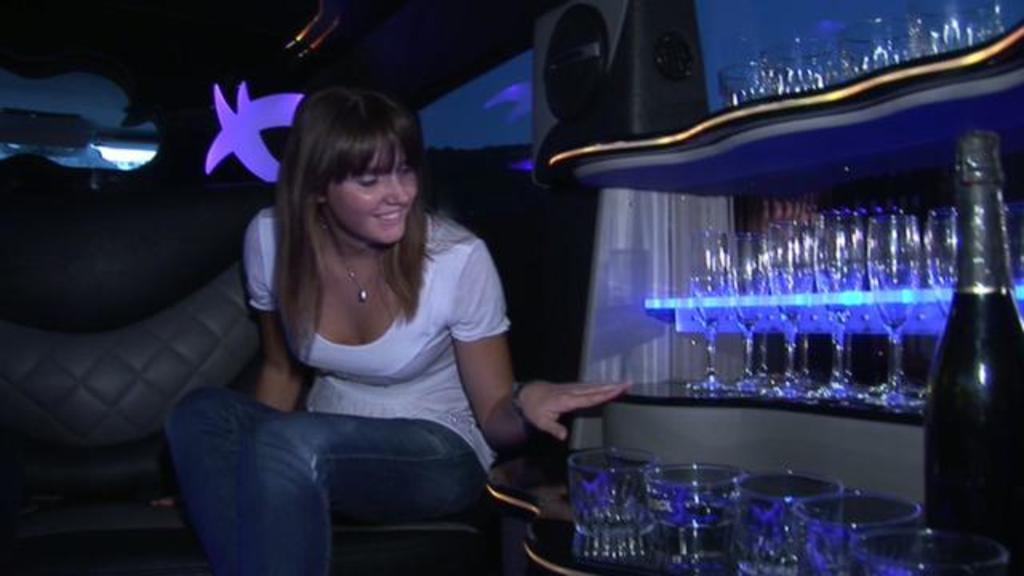What is the woman in the image doing? The woman is sitting on the sofa in the image. Where is the woman located in the image? The woman is on the left side of the image. What objects can be seen in the image besides the woman? There are glasses and a bottle in the image. How are the glasses and bottle arranged in the image? The glasses and bottle are kept in a rack on the right side of the image. What type of oranges can be seen growing on the building in the image? There is no building or oranges present in the image. What is the writer doing in the image? There is no writer present in the image. 